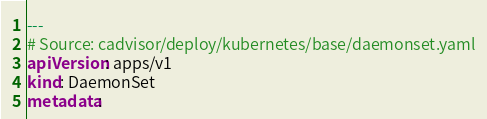Convert code to text. <code><loc_0><loc_0><loc_500><loc_500><_YAML_>---
# Source: cadvisor/deploy/kubernetes/base/daemonset.yaml
apiVersion: apps/v1
kind: DaemonSet
metadata:</code> 